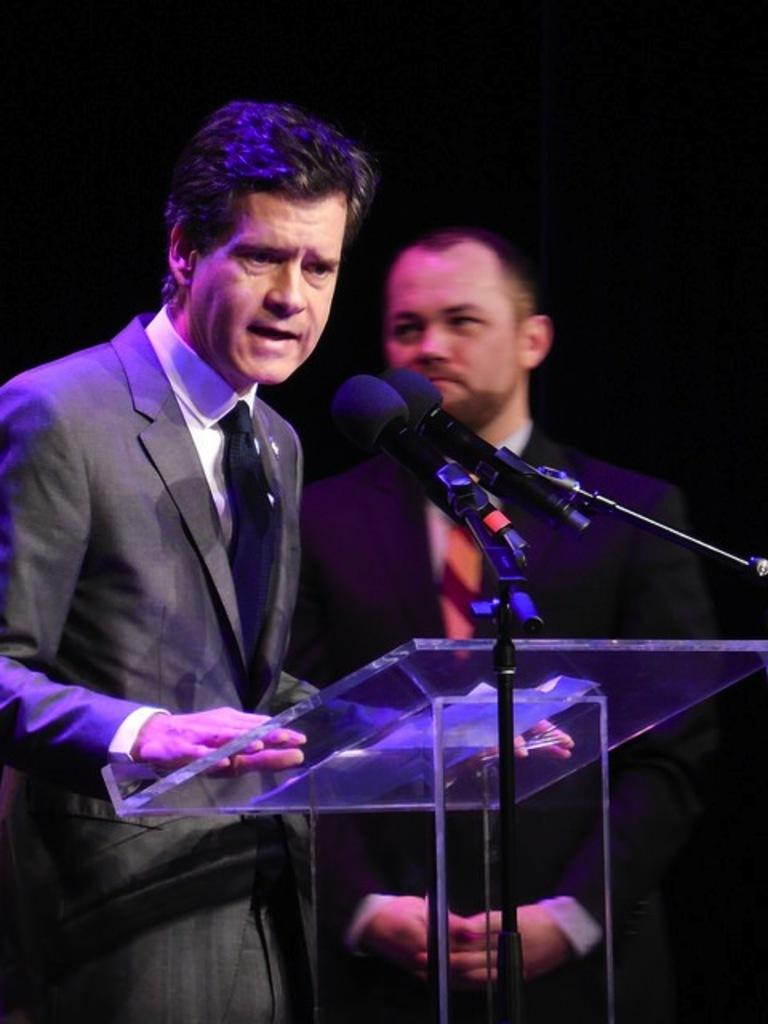What is the main structure in the image? There is a podium in the image. What equipment is present for speaking or recording in the image? There are two microphone stands with two microphones in the image. How many people are near the podium? There are two people standing near the podium. What might be placed on the podium for the people to use? There are objects on the podium. How many houses can be seen in the image? There are no houses visible in the image. Is there a fire hydrant near the podium in the image? There is no fire hydrant present in the image. 